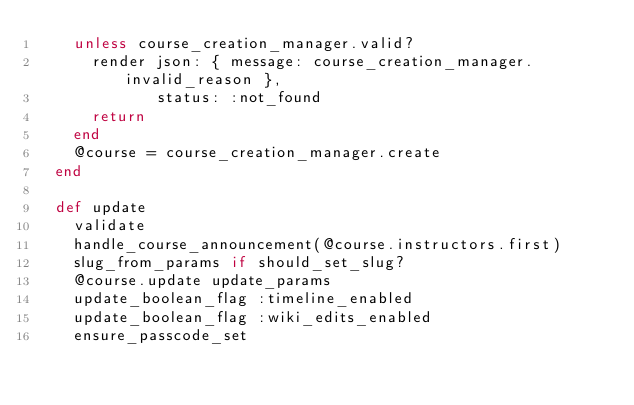<code> <loc_0><loc_0><loc_500><loc_500><_Ruby_>    unless course_creation_manager.valid?
      render json: { message: course_creation_manager.invalid_reason },
             status: :not_found
      return
    end
    @course = course_creation_manager.create
  end

  def update
    validate
    handle_course_announcement(@course.instructors.first)
    slug_from_params if should_set_slug?
    @course.update update_params
    update_boolean_flag :timeline_enabled
    update_boolean_flag :wiki_edits_enabled
    ensure_passcode_set</code> 